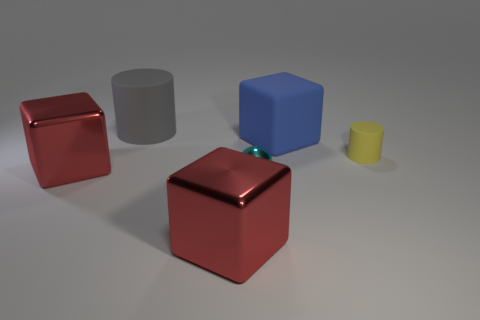How many red cubes must be subtracted to get 1 red cubes? 1 Add 4 big purple shiny spheres. How many objects exist? 10 Subtract all cylinders. How many objects are left? 4 Add 1 cyan shiny spheres. How many cyan shiny spheres are left? 2 Add 6 small yellow metal spheres. How many small yellow metal spheres exist? 6 Subtract 0 purple cylinders. How many objects are left? 6 Subtract all yellow things. Subtract all yellow objects. How many objects are left? 4 